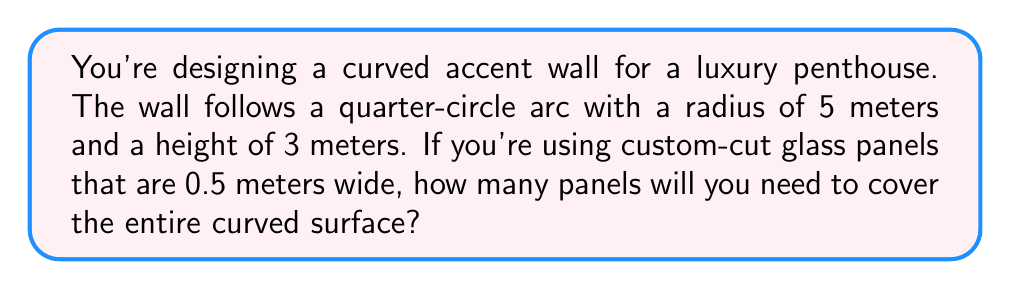What is the answer to this math problem? Let's approach this step-by-step:

1) First, we need to calculate the surface area of the curved wall. The wall forms a quarter of a cylinder's lateral surface.

2) The formula for the lateral surface area of a cylinder is:
   $$A = 2\pi rh$$
   where $r$ is the radius and $h$ is the height.

3) Since we only have a quarter of this surface, we'll divide by 4:
   $$A = \frac{1}{4} \cdot 2\pi rh = \frac{\pi rh}{2}$$

4) Plugging in our values:
   $$A = \frac{\pi \cdot 5m \cdot 3m}{2} = \frac{15\pi}{2} m^2$$

5) Now, we need to determine how many 0.5m wide panels fit along the curved edge. The length of this edge is a quarter of the circumference:
   $$L = \frac{2\pi r}{4} = \frac{\pi r}{2} = \frac{\pi \cdot 5m}{2} = \frac{5\pi}{2} m$$

6) The number of panels is this length divided by the panel width:
   $$N = \frac{5\pi}{2} \div 0.5 = 5\pi$$

7) Since we can't use partial panels, we need to round up to the nearest whole number:
   $$N = \lceil 5\pi \rceil = \lceil 15.71 \rceil = 16$$

Therefore, you will need 16 glass panels to cover the curved wall.
Answer: 16 panels 